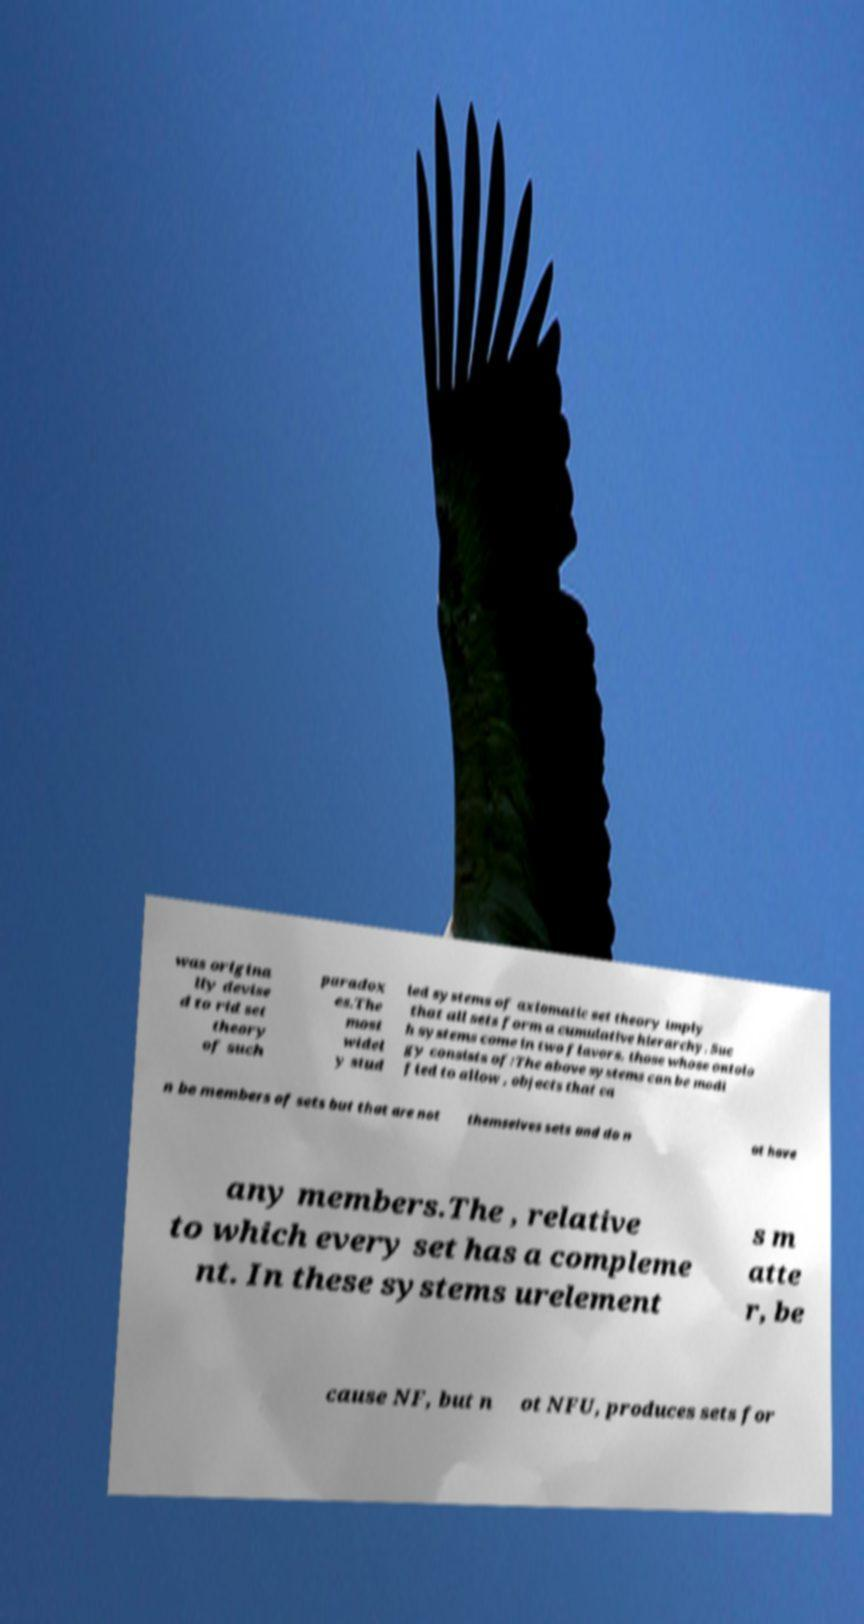Could you extract and type out the text from this image? was origina lly devise d to rid set theory of such paradox es.The most widel y stud ied systems of axiomatic set theory imply that all sets form a cumulative hierarchy. Suc h systems come in two flavors, those whose ontolo gy consists of:The above systems can be modi fied to allow , objects that ca n be members of sets but that are not themselves sets and do n ot have any members.The , relative to which every set has a compleme nt. In these systems urelement s m atte r, be cause NF, but n ot NFU, produces sets for 